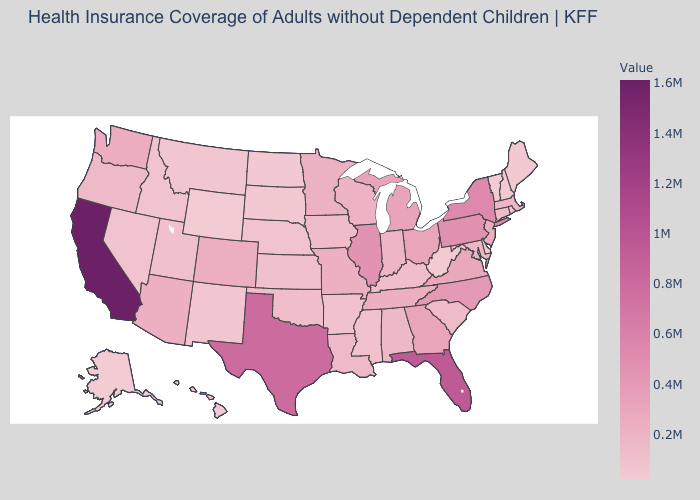Does Nevada have the lowest value in the USA?
Answer briefly. No. Which states have the highest value in the USA?
Be succinct. California. Is the legend a continuous bar?
Answer briefly. Yes. Among the states that border Vermont , does New York have the highest value?
Keep it brief. Yes. Does Alaska have the lowest value in the USA?
Keep it brief. Yes. Does New Hampshire have the highest value in the USA?
Write a very short answer. No. Which states have the lowest value in the USA?
Write a very short answer. Alaska. Does Iowa have a higher value than Virginia?
Short answer required. No. Does Colorado have a lower value than Wyoming?
Quick response, please. No. 